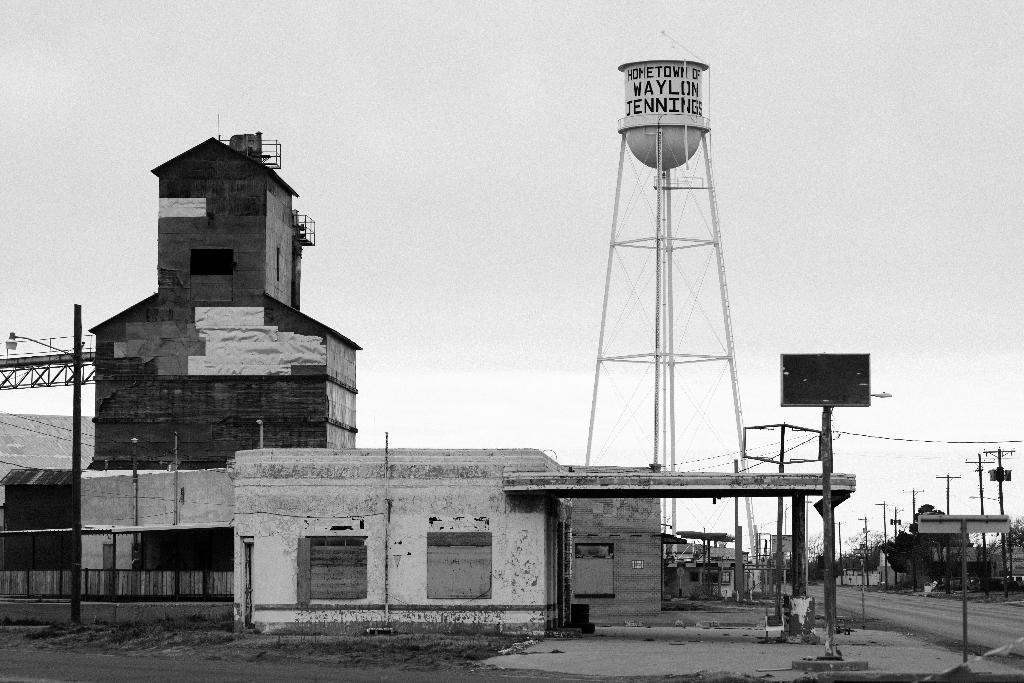Describe this image in one or two sentences. In this picture I can see few buildings and on the right side of this picture I can see the road and I see few poles and in the middle of this picture I can see a tower, on which there is something written. In the background I can see the sky. I can also see that this is a black and white image. On the right side of this image I see few trees. 